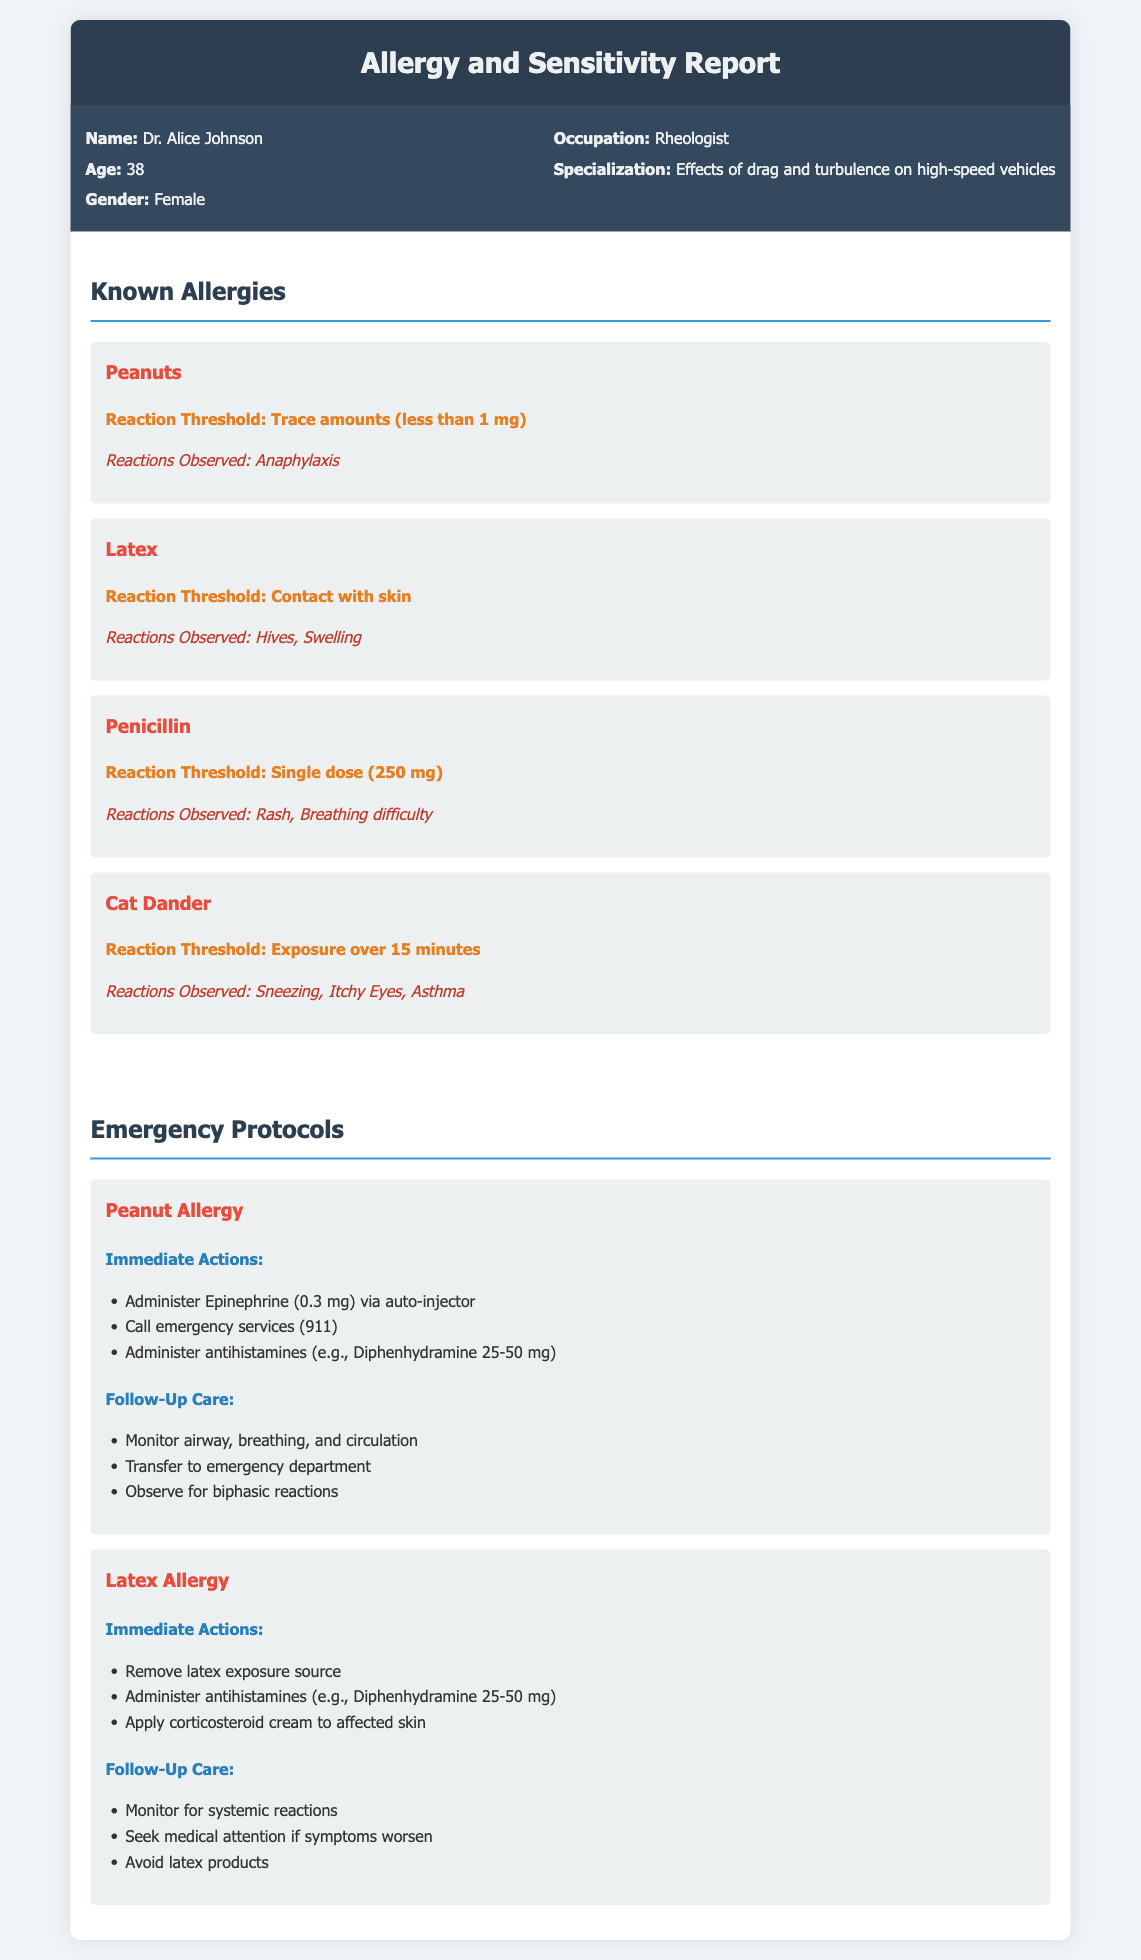What is the patient's name? The patient's name is mentioned in the patient info section of the document.
Answer: Dr. Alice Johnson What occupation does the patient have? The occupation is provided in the patient info section of the document, highlighting the patient's professional details.
Answer: Rheologist What is the threshold for peanut allergy reaction? The reaction threshold for peanut allergy is specified in the allergies section of the document.
Answer: Trace amounts (less than 1 mg) What immediate action should be taken for a peanut allergy? Immediate actions are outlined in the emergency protocols section for the peanut allergy.
Answer: Administer Epinephrine (0.3 mg) via auto-injector What reaction is observed for latex allergy? The observed reactions for latex allergy are listed in the allergies section of the document.
Answer: Hives, Swelling What should be done if symptoms worsen after latex exposure? Follow-up care actions include monitoring and preparing for potential worsening of symptoms as noted in the emergency protocols for latex allergy.
Answer: Seek medical attention if symptoms worsen What is the threshold for cat dander reaction? The threshold is described in the allergies section, detailing the reaction parameters for cat dander.
Answer: Exposure over 15 minutes What follow-up care is suggested after a peanut allergy reaction? The follow-up care for peanut allergy reactions is listed under emergency protocols and outlines necessary actions post-reaction.
Answer: Transfer to emergency department 